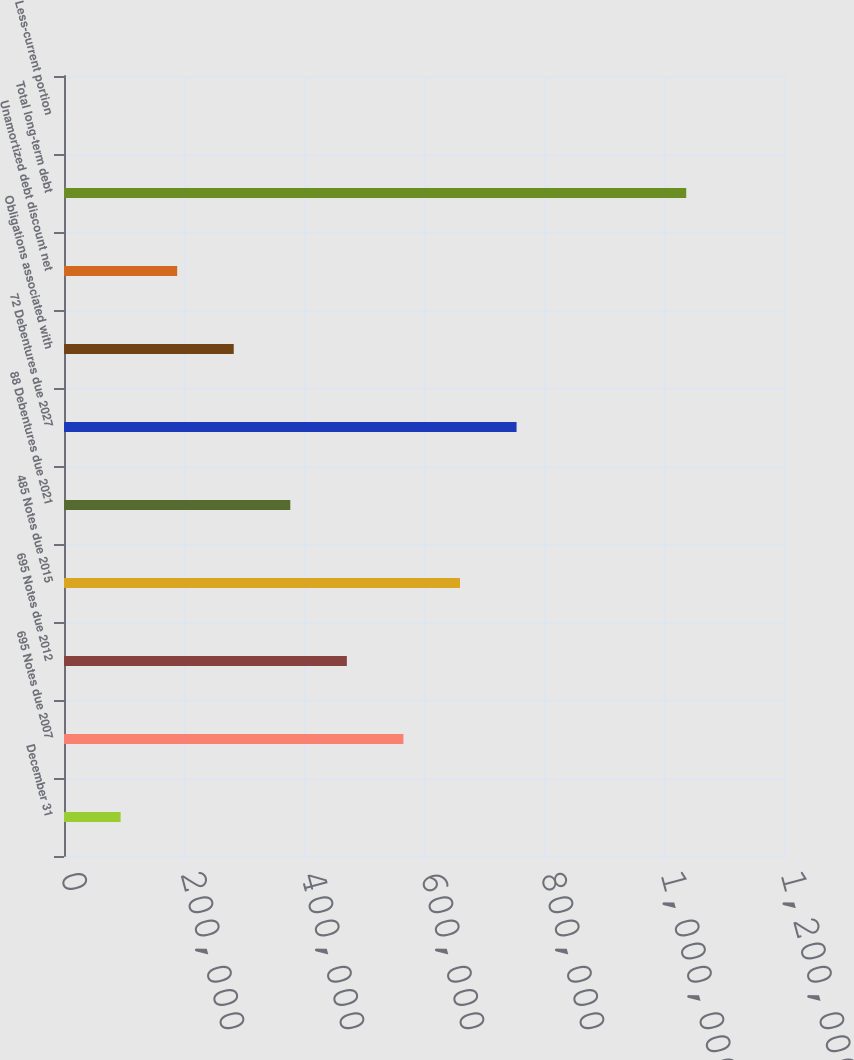Convert chart to OTSL. <chart><loc_0><loc_0><loc_500><loc_500><bar_chart><fcel>December 31<fcel>695 Notes due 2007<fcel>695 Notes due 2012<fcel>485 Notes due 2015<fcel>88 Debentures due 2021<fcel>72 Debentures due 2027<fcel>Obligations associated with<fcel>Unamortized debt discount net<fcel>Total long-term debt<fcel>Less-current portion<nl><fcel>94331.5<fcel>565709<fcel>471434<fcel>659984<fcel>377158<fcel>754260<fcel>282882<fcel>188607<fcel>1.03703e+06<fcel>56<nl></chart> 